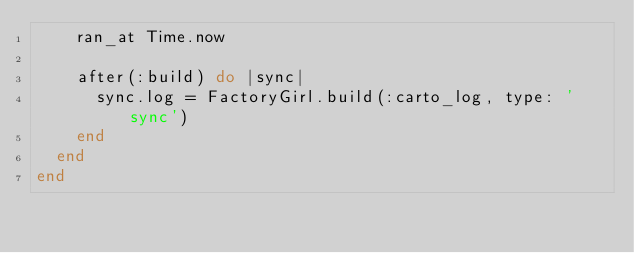<code> <loc_0><loc_0><loc_500><loc_500><_Ruby_>    ran_at Time.now

    after(:build) do |sync|
      sync.log = FactoryGirl.build(:carto_log, type: 'sync')
    end
  end
end
</code> 